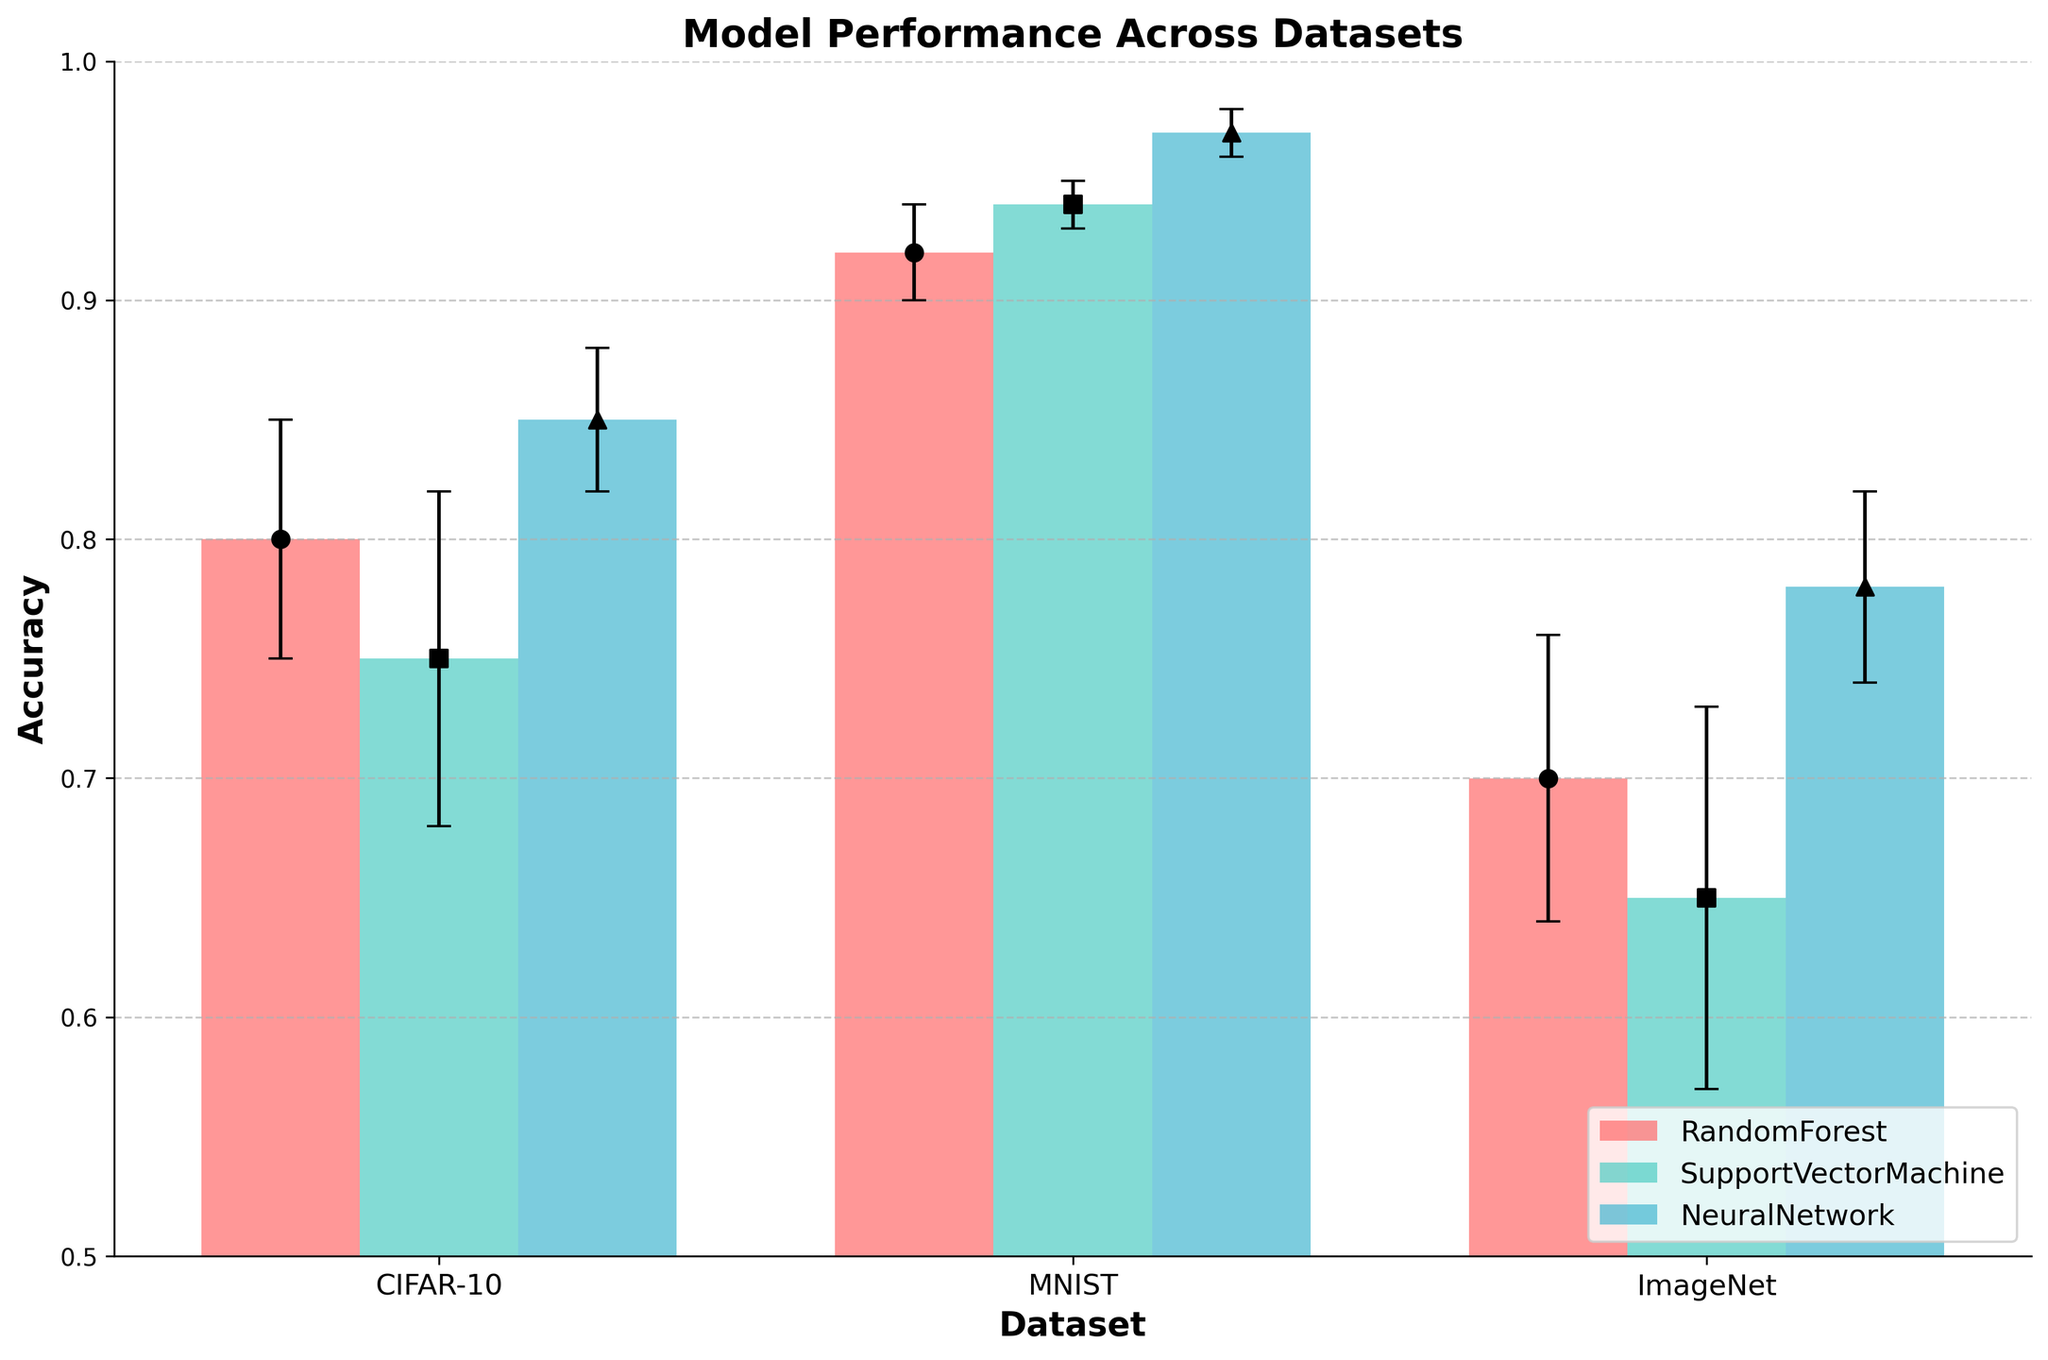What's the title of the figure? The title of the figure is displayed at the top and should describe the main topic or content of the plot.
Answer: Model Performance Across Datasets How many datasets are represented in the figure? By looking at the x-axis labels, you can count the distinct dataset names displayed.
Answer: 3 Which algorithm has the highest mean accuracy on the MNIST dataset? Find the bar corresponding to the MNIST dataset and compare the heights of the bars for different algorithms. The tallest bar represents the highest mean accuracy.
Answer: NeuralNetwork What is the range of the accuracy shown in the figure? Look at the y-axis and note the minimum and maximum values displayed.
Answer: 0.5 to 1.0 Which algorithm shows the largest variability in performance on the CIFAR-10 dataset? Compare the error bars for each algorithm on the CIFAR-10 dataset. The algorithm with the largest error bar shows the largest variability.
Answer: SupportVectorMachine On which dataset does the RandomForest algorithm perform the best? Compare the heights of the bars for the RandomForest algorithm across all datasets. The tallest bar indicates the best performance.
Answer: MNIST By how much does the mean accuracy of the NeuralNetwork algorithm on CIFAR-10 differ from that on ImageNet? Find the mean accuracy values for the NeuralNetwork algorithm on CIFAR-10 and ImageNet, and then subtract them.
Answer: 0.07 Which dataset shows the smallest overall variability in performance across all algorithms? Compare the lengths of the error bars for all algorithms across all datasets. The dataset with the shortest error bars overall shows the smallest variability.
Answer: MNIST Is there any algorithm that performs consistently close to 0.75 across all datasets? Check the mean accuracies of each algorithm on all datasets. Look for an algorithm whose bars are close to 0.75 in height consistently.
Answer: No Which algorithm's performance varies the least across different datasets based on error bars? Compare the lengths of the error bars for each algorithm across all datasets. The algorithm with the shortest error bars overall has the least variability in performance.
Answer: NeuralNetwork 